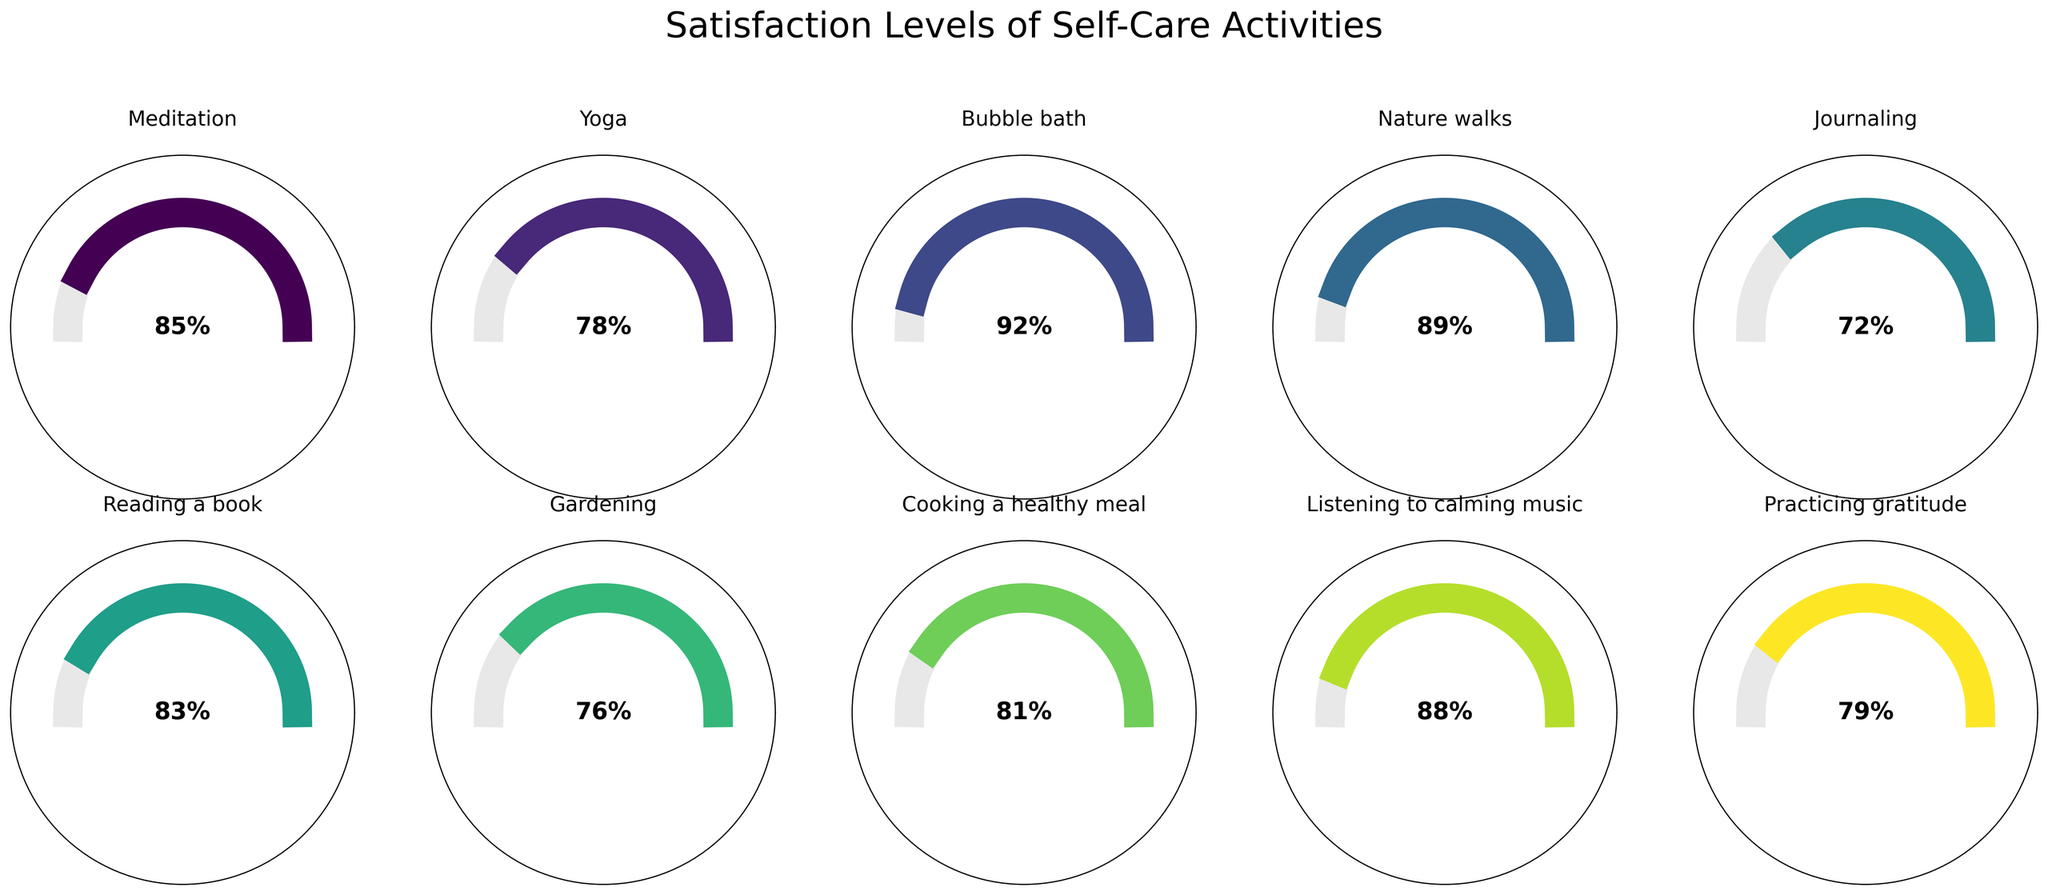What is the satisfaction level for Nature walks? Locate the gauge for "Nature walks" and read the percentage inside it.
Answer: 89% Which self-care activity has the highest satisfaction level? Compare all the gauges and identify the one with the highest percentage.
Answer: Bubble bath What is the title of the figure? Look at the text at the top of the figure.
Answer: Satisfaction Levels of Self-Care Activities How many self-care activities have a satisfaction level above 80%? Count the gauges with satisfaction levels above 80%.
Answer: Six What is the average satisfaction level of all listed self-care activities? Sum all satisfaction percentages and divide by the number of activities: (85 + 78 + 92 + 89 + 72 + 83 + 76 + 81 + 88 + 79)/10 =  82.3
Answer: 82.3 Which activity has a higher satisfaction level, Journaling or Cooking a healthy meal? Compare the satisfaction percentages of "Journaling" and "Cooking a healthy meal".
Answer: Cooking a healthy meal What is the difference in satisfaction levels between Yoga and Reading a book? Subtract the satisfaction level of yoga from that of reading a book: 83 - 78 = 5
Answer: 5 Which self-care activity is rated closest to 90% satisfaction? Identify the gauge whose satisfaction level is closest to 90%.
Answer: Nature walks Are there more activities rated above or below 80% satisfaction? Count the activities rated above and below 80%, then compare the counts.
Answer: Above 